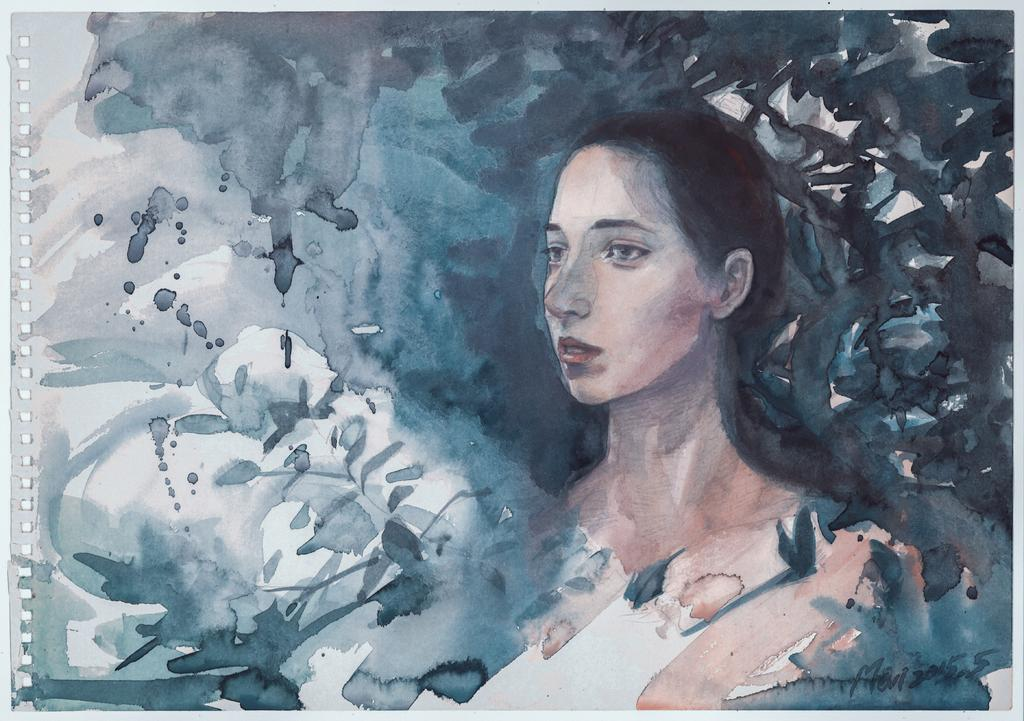What is the main subject of the image? There is a painting in the image. What does the painting depict? The painting depicts a girl. Can you tell me how the snake is helping the girl in the painting? There is no snake present in the painting; it depicts a girl only. 